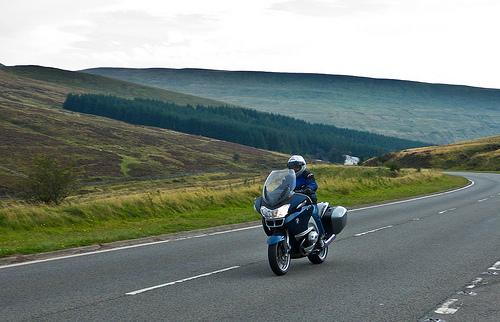Summarize the primary focus of the image and its surrounding elements. A man is riding a motorcycle on a highway, with a helmet and jacket on, surrounded by grass fields, trees on a hill, white lines on the road, and a sky with a few clouds. In a few words, illustrate the central figure in the photo and the notable elements around them. Helmeted biker on highway, grass and trees nearby, cloudy sky above, white lines on road. Mention the core subject in the scene and describe the environment around it. A man wearing protective gear rides his motorcycle down an asphalt road bordered by grassy areas, hills with trees, and distinct white lane markings under a lightly cloudy sky. Provide a concise description of the main individual in the picture and the context in which they are placed. A helmeted motorcyclist wearing a jacket journeys down a street lined with grassy fields, trees, and hills, with white lines separating the lanes and clouds scattered in the sky. Mention the key subject, their actions, and the setting briefly. Man on motorcycle with helmet, jacket, riding on road, surrounded by grass, trees, hills, and clouds. Briefly depict the central object of the image and its actions along with notable background details. A motorcyclist, wearing a helmet and jacket, speeds down a two-lane highway fringed by tall grass, hills, and foliage, all under a partially cloudy sky. Provide a quick summary of the main object, its actions, and setting. Biker in gear on highway, grassy hills, trees, white road lines, and light-clouded sky. Outline the key aspect of the image, what it is doing, and the prominent environment around it. Biker with helmet, jacket, traveling on road, flanked by grass, green hills, white markings, and some clouds. Using brief language, explain the primary character in the image, what they are doing, and the surrounding atmosphere. Motorcyclist in helmet and jacket rides on road, amid grass, hills, trees, white road lines, and mildly cloudy sky. State the chief character in the picture, its actions, and surroundings. Helmeted motorcyclist, cruising on road, among grass fields, treed hills, white lines, and sparse clouds. 